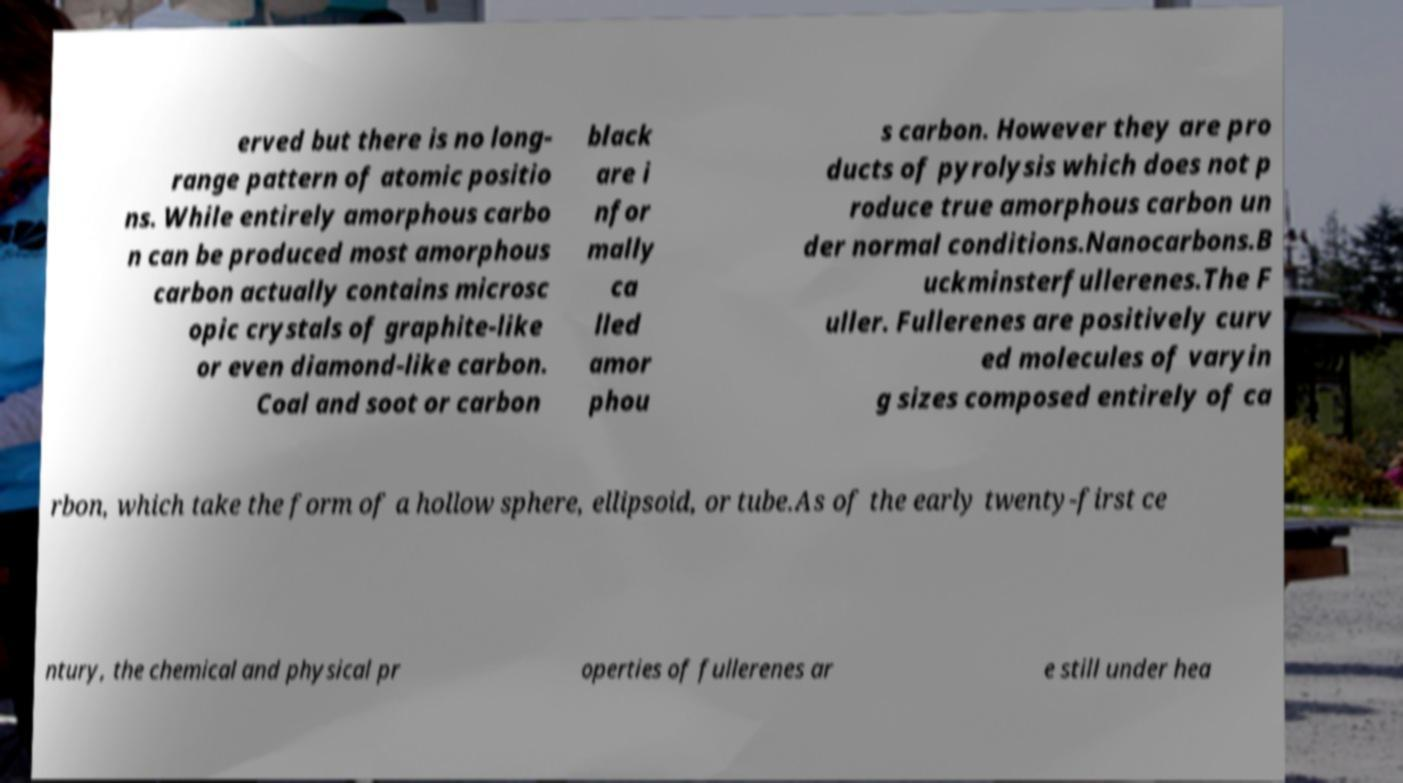Could you extract and type out the text from this image? erved but there is no long- range pattern of atomic positio ns. While entirely amorphous carbo n can be produced most amorphous carbon actually contains microsc opic crystals of graphite-like or even diamond-like carbon. Coal and soot or carbon black are i nfor mally ca lled amor phou s carbon. However they are pro ducts of pyrolysis which does not p roduce true amorphous carbon un der normal conditions.Nanocarbons.B uckminsterfullerenes.The F uller. Fullerenes are positively curv ed molecules of varyin g sizes composed entirely of ca rbon, which take the form of a hollow sphere, ellipsoid, or tube.As of the early twenty-first ce ntury, the chemical and physical pr operties of fullerenes ar e still under hea 